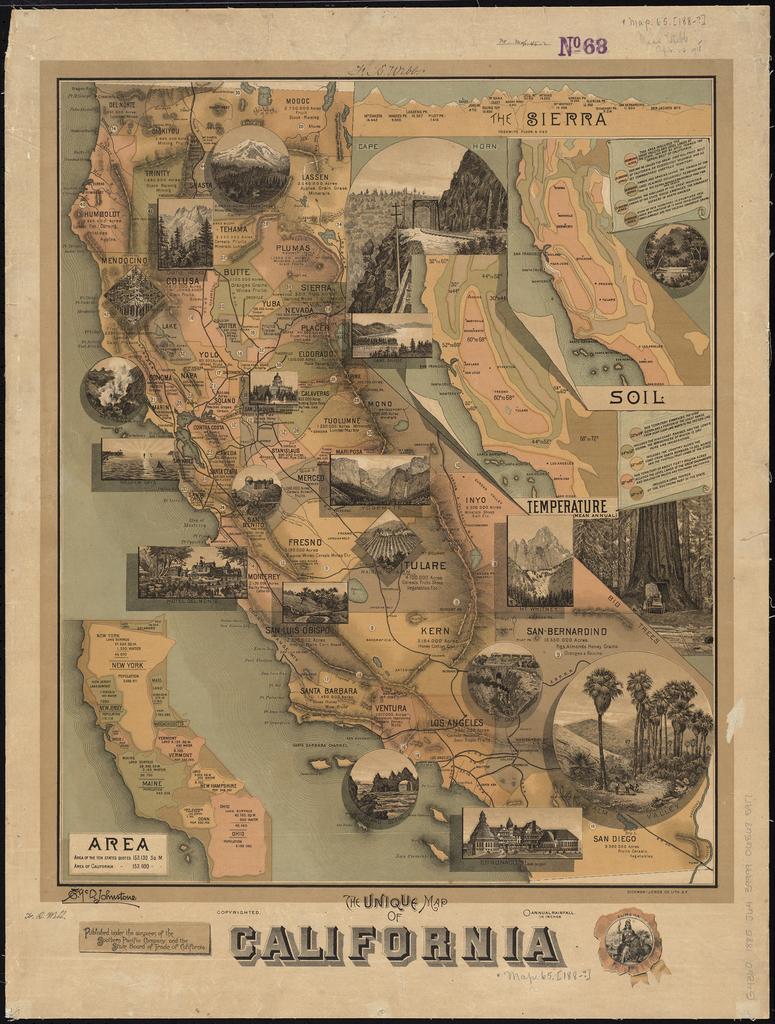Is that a map of california?
Offer a terse response. Yes. What state is this?
Your answer should be compact. California. 